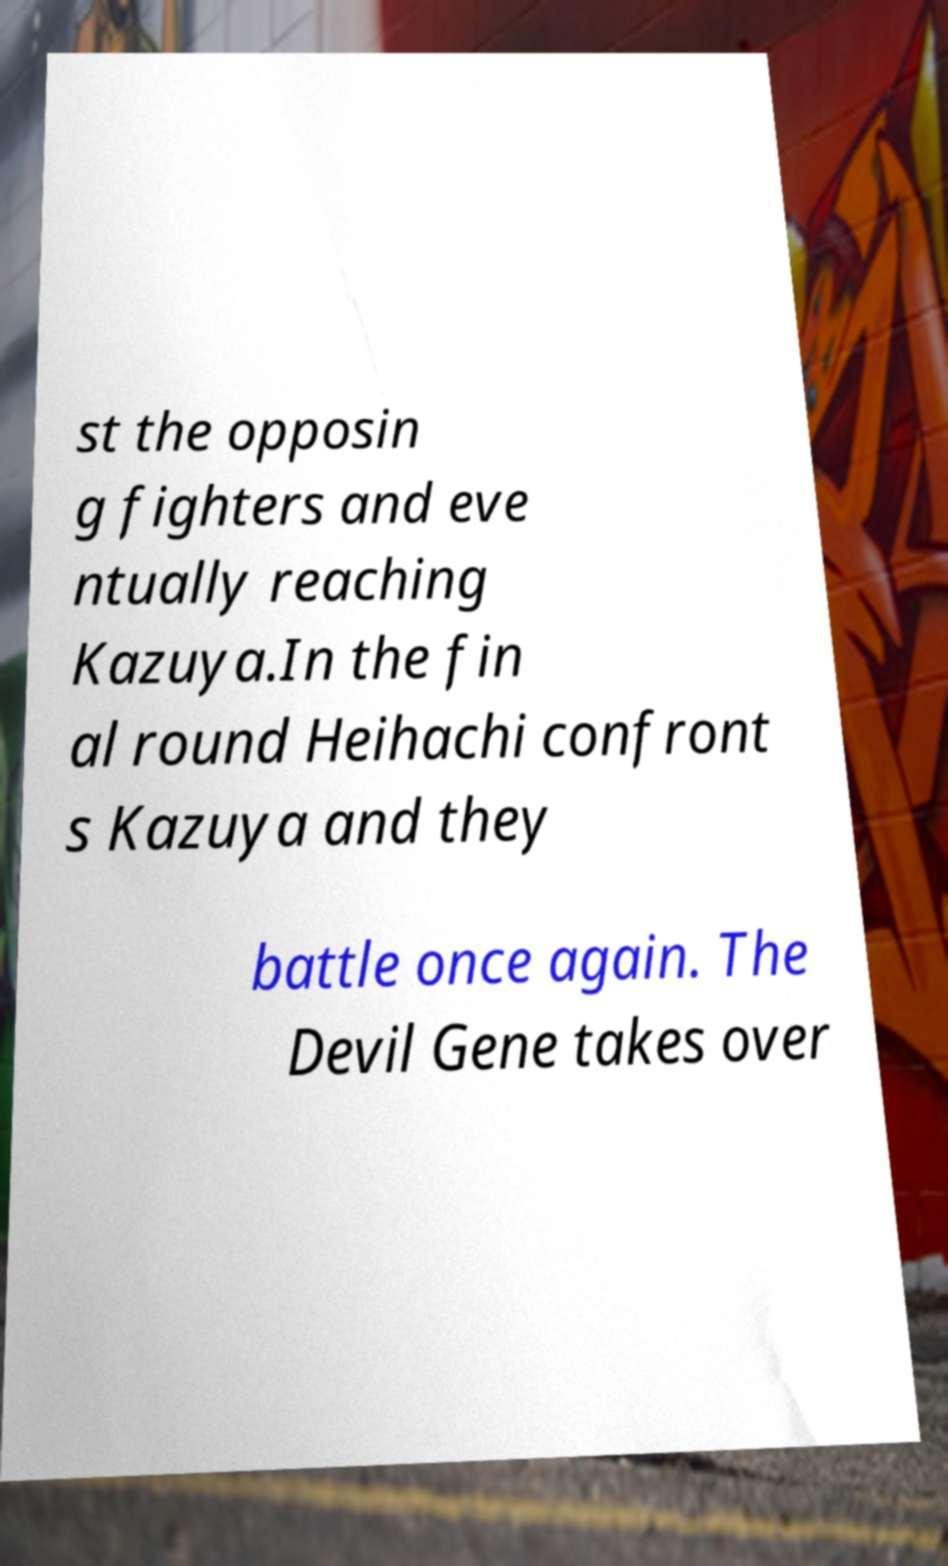There's text embedded in this image that I need extracted. Can you transcribe it verbatim? st the opposin g fighters and eve ntually reaching Kazuya.In the fin al round Heihachi confront s Kazuya and they battle once again. The Devil Gene takes over 